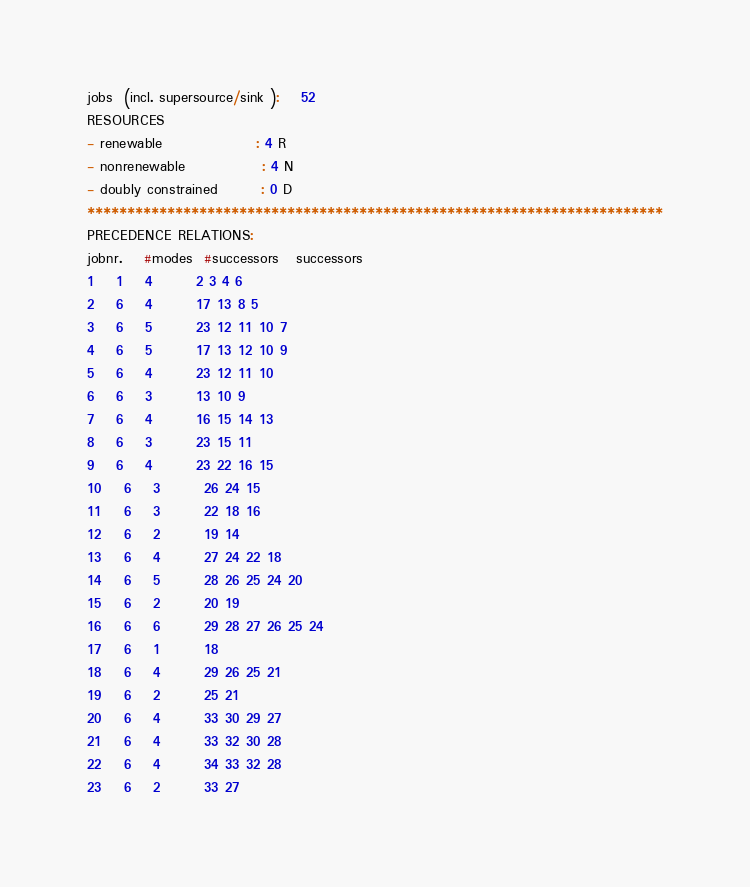<code> <loc_0><loc_0><loc_500><loc_500><_ObjectiveC_>jobs  (incl. supersource/sink ):	52
RESOURCES
- renewable                 : 4 R
- nonrenewable              : 4 N
- doubly constrained        : 0 D
************************************************************************
PRECEDENCE RELATIONS:
jobnr.    #modes  #successors   successors
1	1	4		2 3 4 6 
2	6	4		17 13 8 5 
3	6	5		23 12 11 10 7 
4	6	5		17 13 12 10 9 
5	6	4		23 12 11 10 
6	6	3		13 10 9 
7	6	4		16 15 14 13 
8	6	3		23 15 11 
9	6	4		23 22 16 15 
10	6	3		26 24 15 
11	6	3		22 18 16 
12	6	2		19 14 
13	6	4		27 24 22 18 
14	6	5		28 26 25 24 20 
15	6	2		20 19 
16	6	6		29 28 27 26 25 24 
17	6	1		18 
18	6	4		29 26 25 21 
19	6	2		25 21 
20	6	4		33 30 29 27 
21	6	4		33 32 30 28 
22	6	4		34 33 32 28 
23	6	2		33 27 </code> 